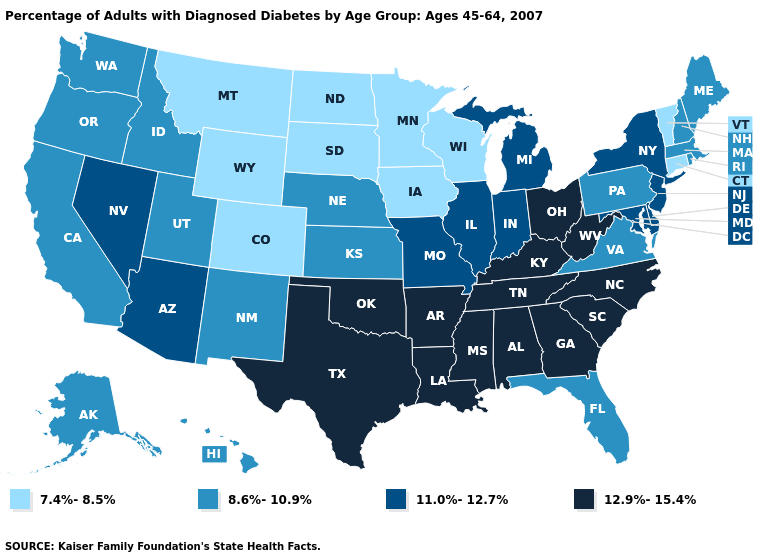Does Nevada have a higher value than Connecticut?
Concise answer only. Yes. Does New York have the highest value in the Northeast?
Short answer required. Yes. Does Alaska have the same value as Oregon?
Quick response, please. Yes. Does Nevada have a lower value than Nebraska?
Concise answer only. No. Does the first symbol in the legend represent the smallest category?
Short answer required. Yes. Among the states that border Georgia , which have the highest value?
Be succinct. Alabama, North Carolina, South Carolina, Tennessee. What is the value of Kentucky?
Write a very short answer. 12.9%-15.4%. Among the states that border South Carolina , which have the lowest value?
Keep it brief. Georgia, North Carolina. Which states hav the highest value in the Northeast?
Short answer required. New Jersey, New York. What is the value of South Dakota?
Concise answer only. 7.4%-8.5%. Is the legend a continuous bar?
Quick response, please. No. Which states have the lowest value in the Northeast?
Be succinct. Connecticut, Vermont. What is the highest value in the South ?
Write a very short answer. 12.9%-15.4%. What is the value of Ohio?
Concise answer only. 12.9%-15.4%. What is the highest value in the MidWest ?
Quick response, please. 12.9%-15.4%. 